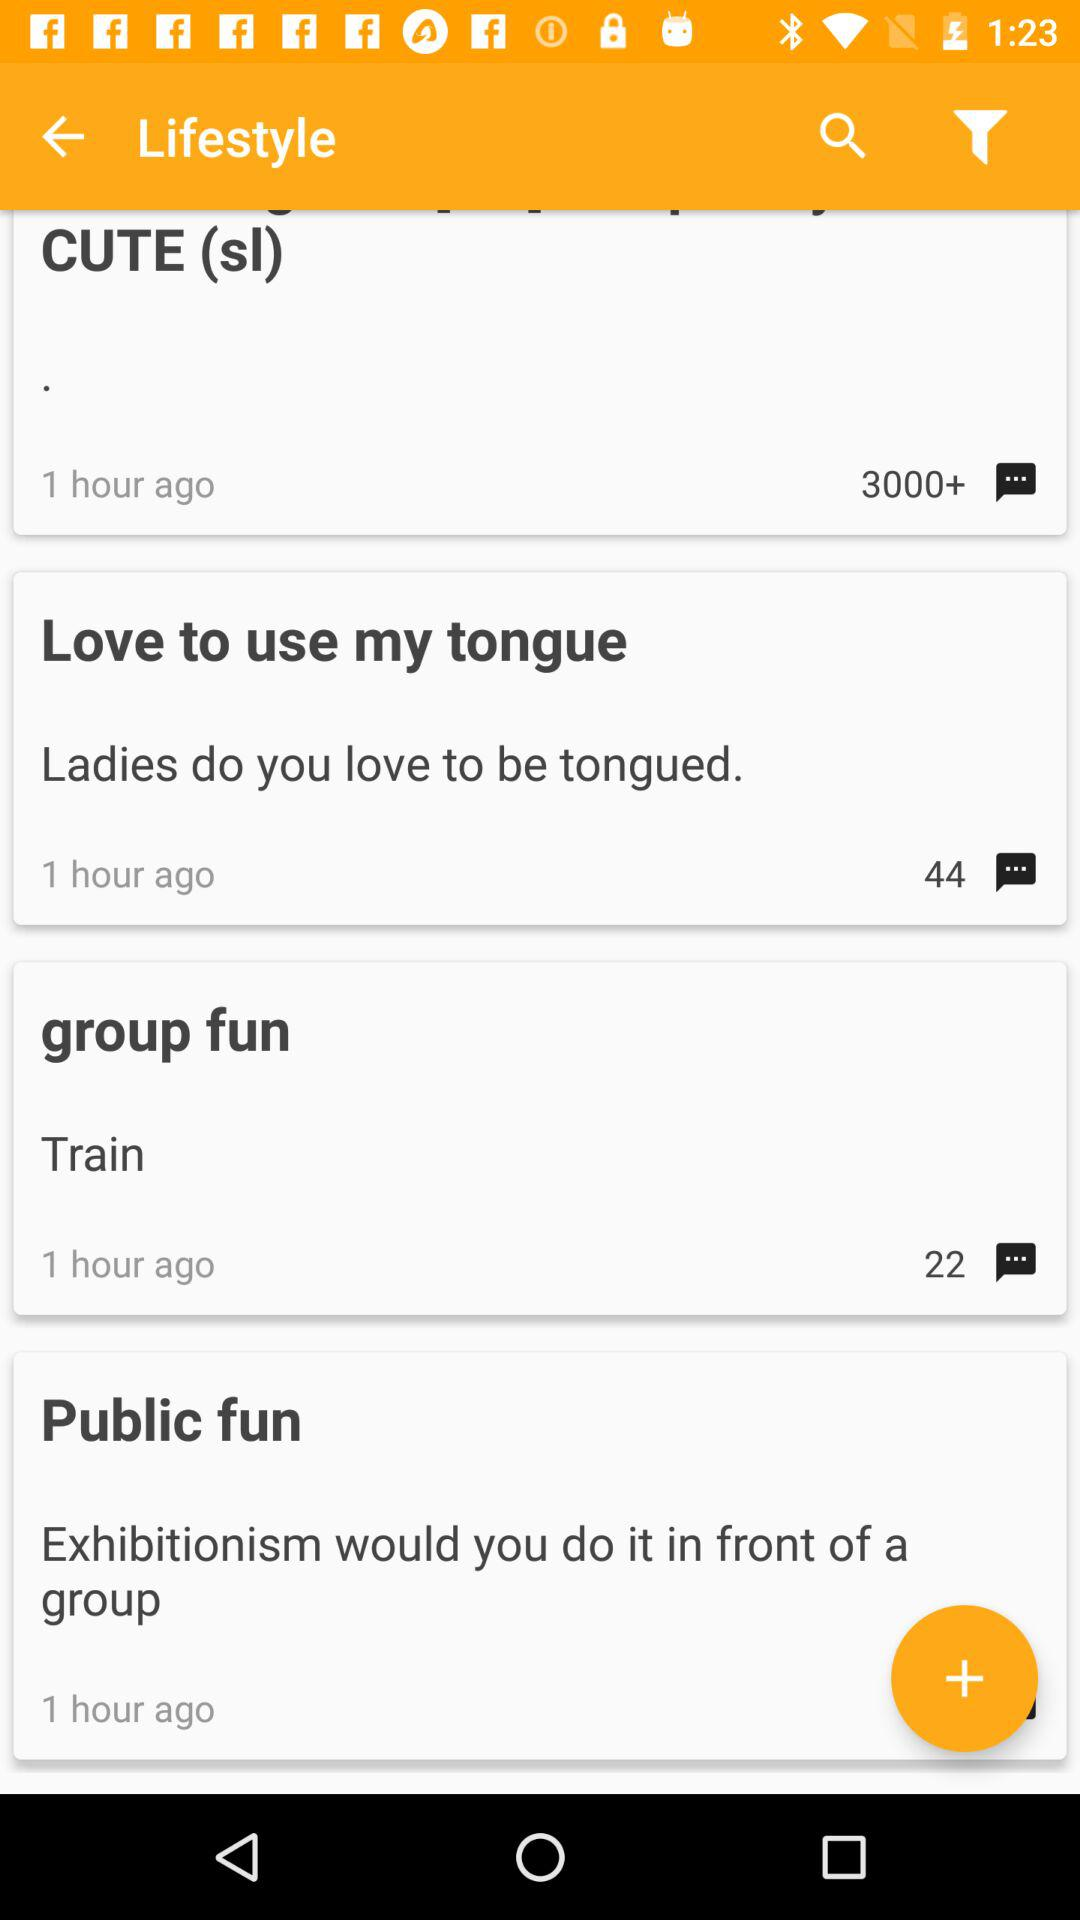What is the count of comments in group fun? The count of comments in group fun is 22. 